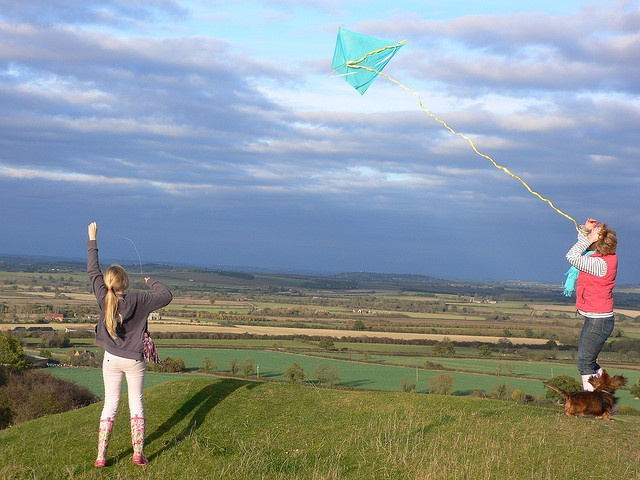Describe the objects in this image and their specific colors. I can see people in darkgray, gray, white, and tan tones, people in darkgray, salmon, gray, white, and brown tones, kite in darkgray, cyan, turquoise, lightgray, and khaki tones, and dog in darkgray, maroon, black, and brown tones in this image. 